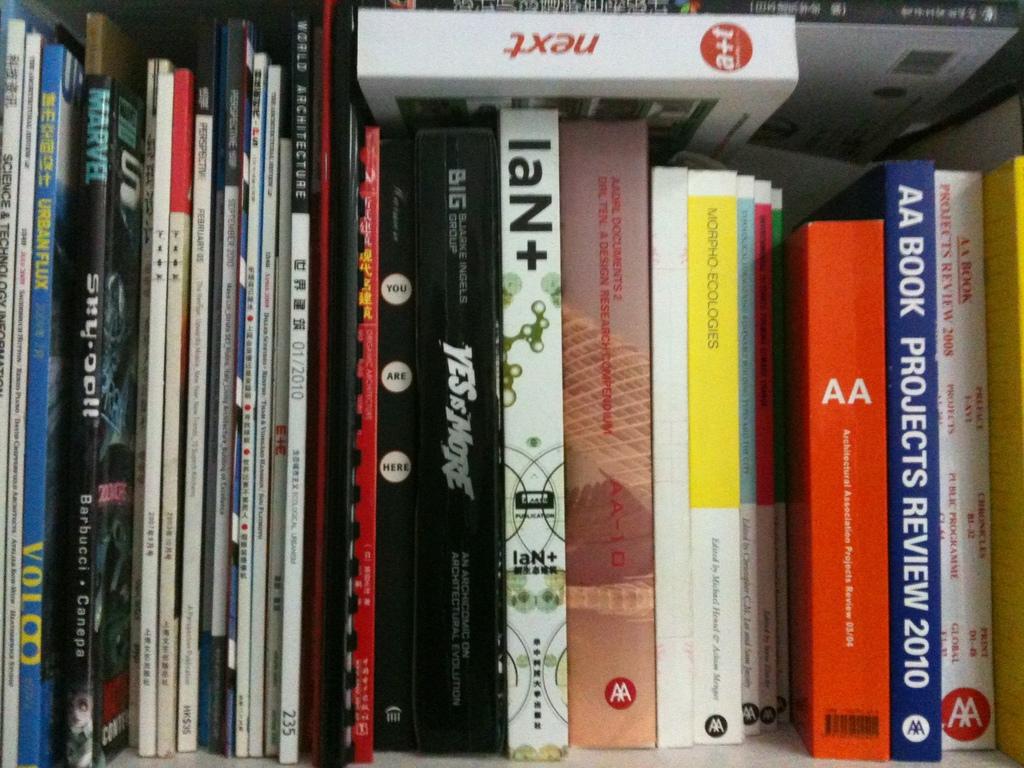What is the blue book on the right a review of?
Keep it short and to the point. Projects. What is the name of the book on the top?
Give a very brief answer. Next. 